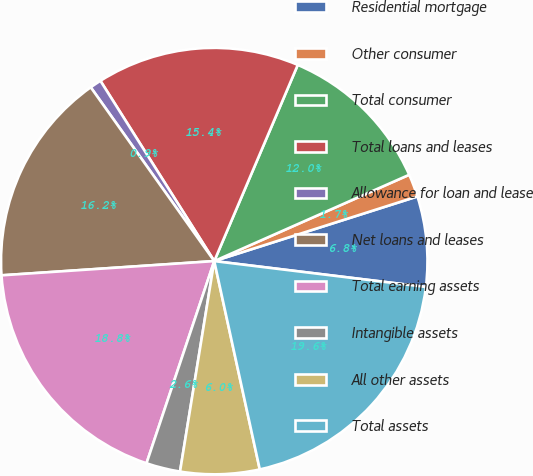Convert chart. <chart><loc_0><loc_0><loc_500><loc_500><pie_chart><fcel>Residential mortgage<fcel>Other consumer<fcel>Total consumer<fcel>Total loans and leases<fcel>Allowance for loan and lease<fcel>Net loans and leases<fcel>Total earning assets<fcel>Intangible assets<fcel>All other assets<fcel>Total assets<nl><fcel>6.84%<fcel>1.73%<fcel>11.96%<fcel>15.37%<fcel>0.87%<fcel>16.23%<fcel>18.79%<fcel>2.58%<fcel>5.99%<fcel>19.64%<nl></chart> 